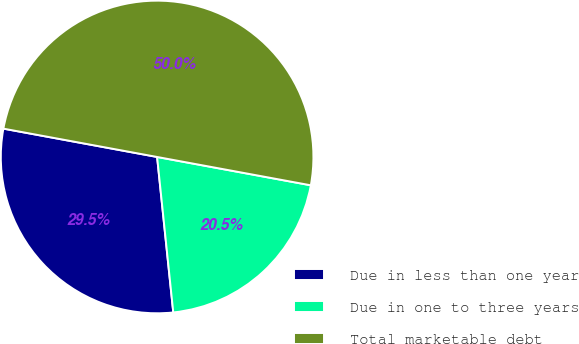Convert chart. <chart><loc_0><loc_0><loc_500><loc_500><pie_chart><fcel>Due in less than one year<fcel>Due in one to three years<fcel>Total marketable debt<nl><fcel>29.55%<fcel>20.45%<fcel>50.0%<nl></chart> 